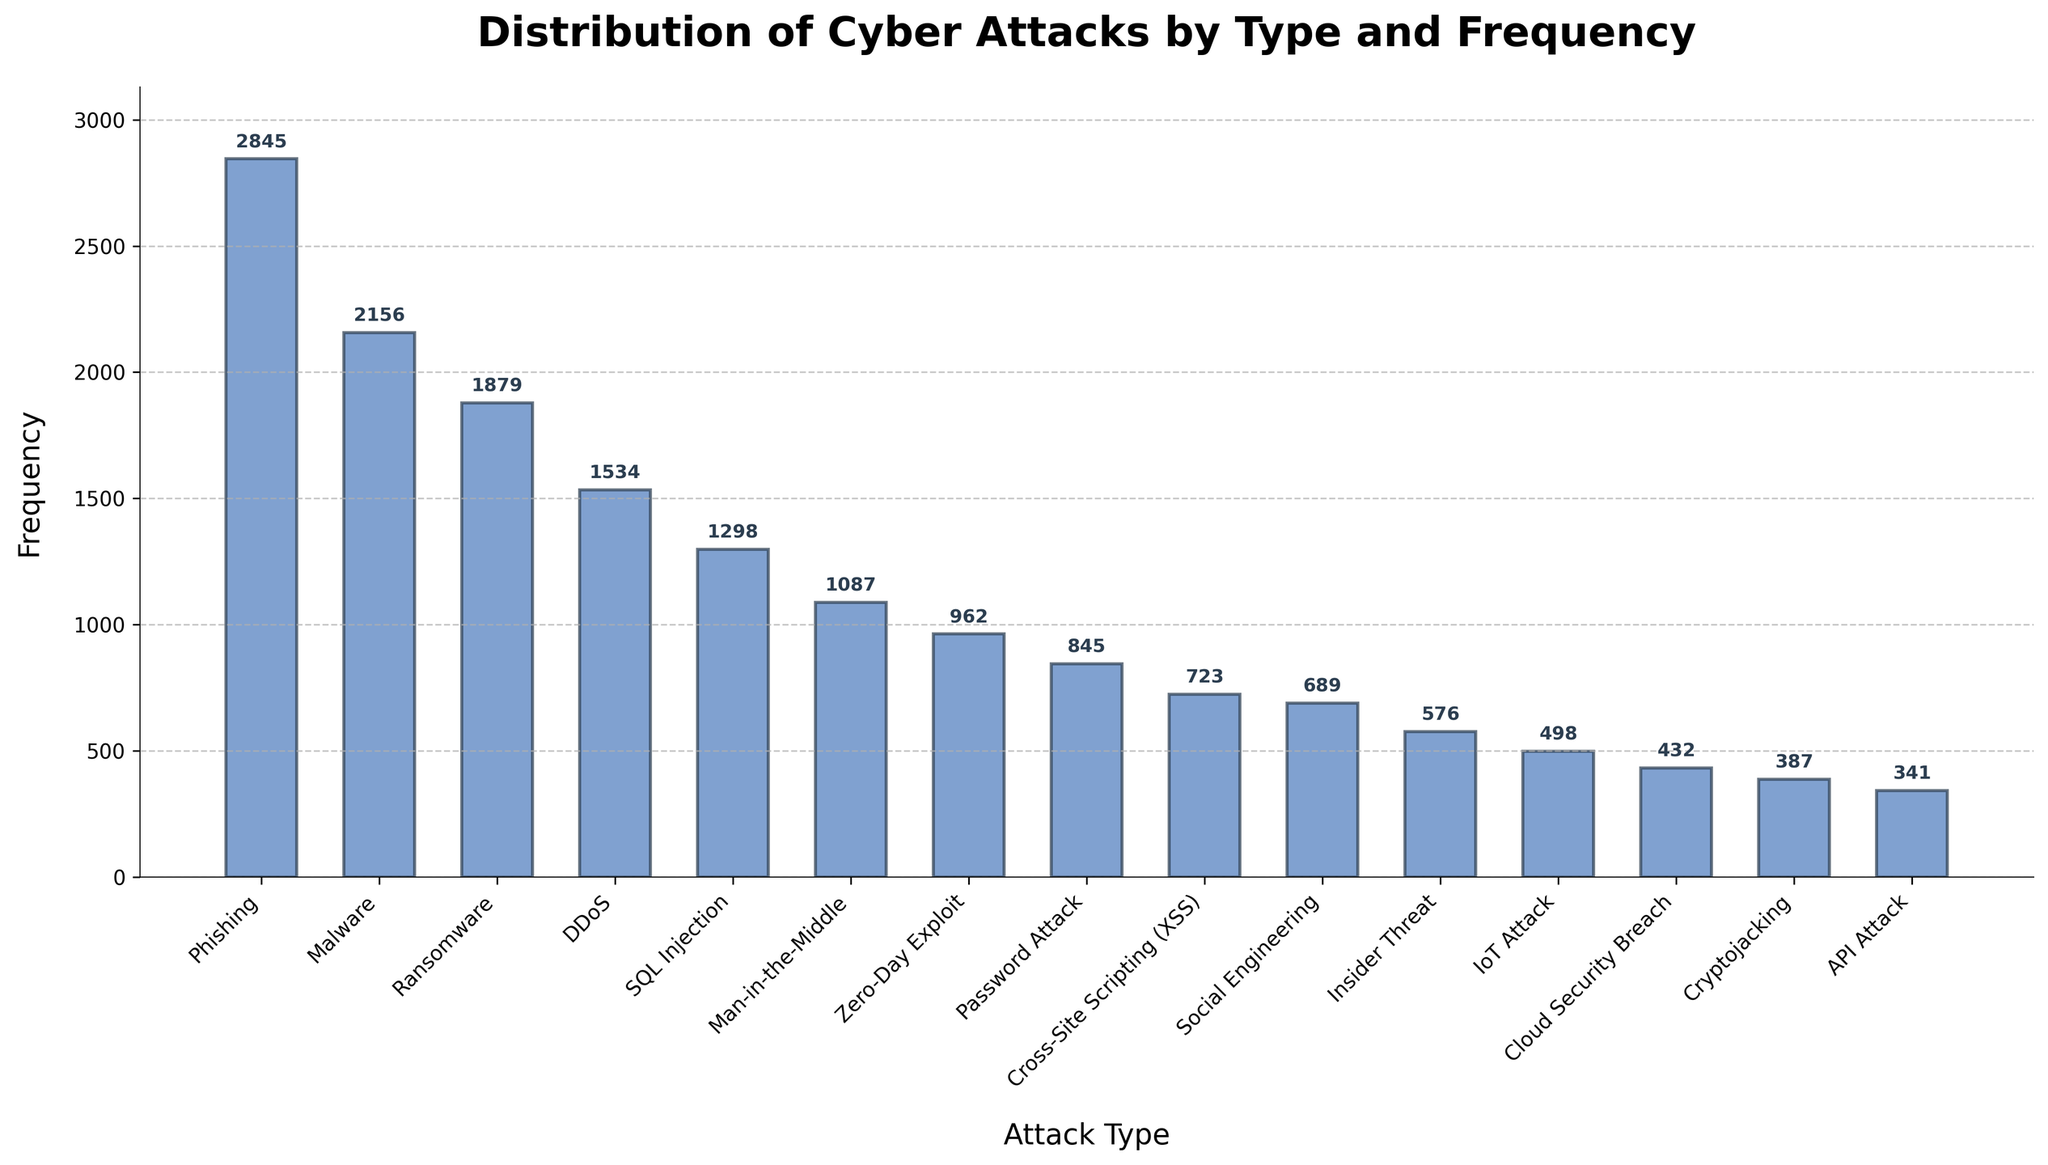Which type of cyber attack has the highest frequency? By looking at the heights of the bars, identify the tallest one, which represents the highest frequency. The tallest bar corresponds to Phishing with a frequency of 2845.
Answer: Phishing Between Ransomware and DDoS attacks, which one is more frequent? Compare the heights of the bars for Ransomware and DDoS. The Ransomware bar is taller than the DDoS bar.
Answer: Ransomware What is the combined frequency of SQL Injection and Man-in-the-Middle attacks? Add the frequencies of SQL Injection (1298) and Man-in-the-Middle (1087) by summing them up. 1298 + 1087 = 2385.
Answer: 2385 How much more frequent are Phishing attacks than IoT Attacks? Calculate the difference by subtracting the frequency of IoT Attacks (498) from the frequency of Phishing (2845). 2845 - 498 = 2347.
Answer: 2347 Which type of attack has the lowest frequency and what is that frequency? Find the shortest bar in the chart, which corresponds to API Attack with a frequency of 341.
Answer: API Attack, 341 Order the following attacks from most to least frequent: Malware, Zero-Day Exploit, Insider Threat. Compare the heights of the bars for these attacks: Malware (2156), Zero-Day Exploit (962), and Insider Threat (576). The order is Malware > Zero-Day Exploit > Insider Threat.
Answer: Malware, Zero-Day Exploit, Insider Threat What is the average frequency of the top three most frequent attack types? Identify the top three attack types: Phishing (2845), Malware (2156), and Ransomware (1879). Calculate the average: (2845 + 2156 + 1879) / 3 ≈ 2293.33.
Answer: 2293.33 How many types of attacks have a frequency greater than 1000? Count the bars with a height corresponding to a frequency greater than 1000: Phishing, Malware, Ransomware, DDoS, SQL Injection, and Man-in-the-Middle. There are 6 such attack types.
Answer: 6 Is the frequency of Cross-Site Scripting (XSS) attacks greater than the frequency of Social Engineering attacks? Compare the heights of the bars for XSS (723) and Social Engineering (689). The XSS bar is slightly taller.
Answer: Yes Which attack types have a frequency between 500 and 1000? Identify the bars within the specified range: Password Attack (845), XSS (723), Social Engineering (689), Insider Threat (576), and IoT Attack (498, which is just below 500).
Answer: Password Attack, Cross-Site Scripting (XSS), Social Engineering, Insider Threat 